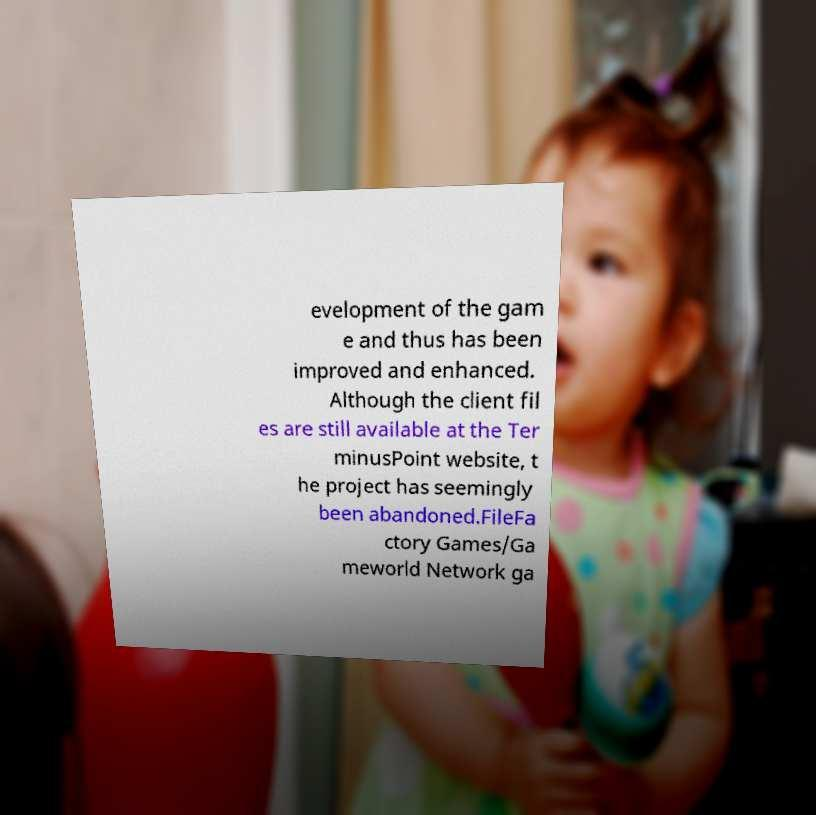Can you read and provide the text displayed in the image?This photo seems to have some interesting text. Can you extract and type it out for me? evelopment of the gam e and thus has been improved and enhanced. Although the client fil es are still available at the Ter minusPoint website, t he project has seemingly been abandoned.FileFa ctory Games/Ga meworld Network ga 